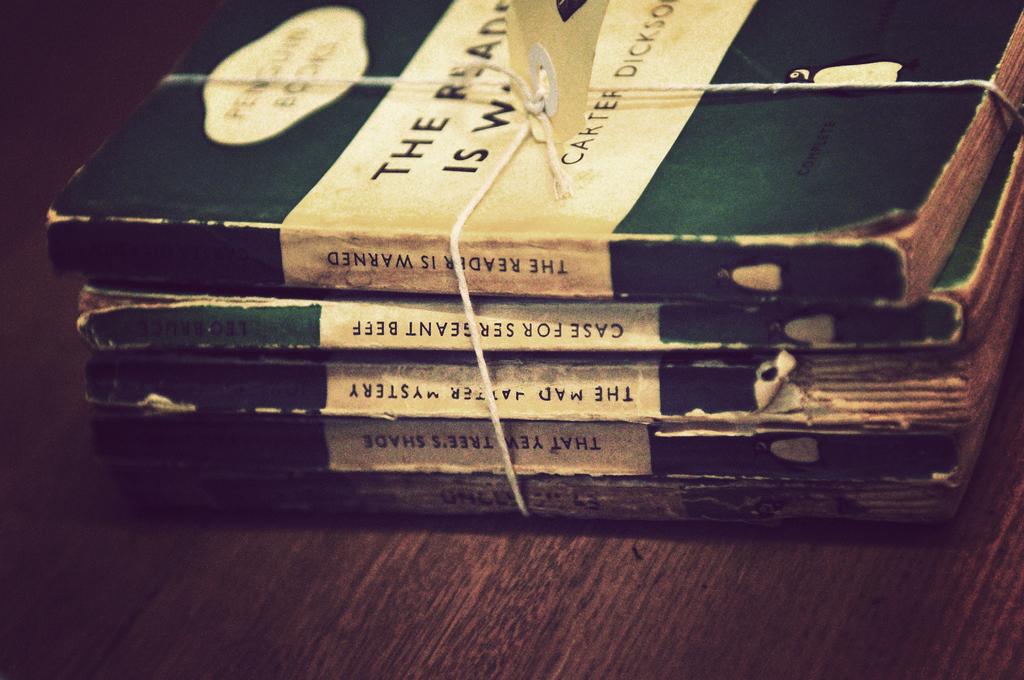What is the title of the top book?
Ensure brevity in your answer.  The reader is warned. What is the title of the bottom book?
Your answer should be very brief. Unanswerable. 